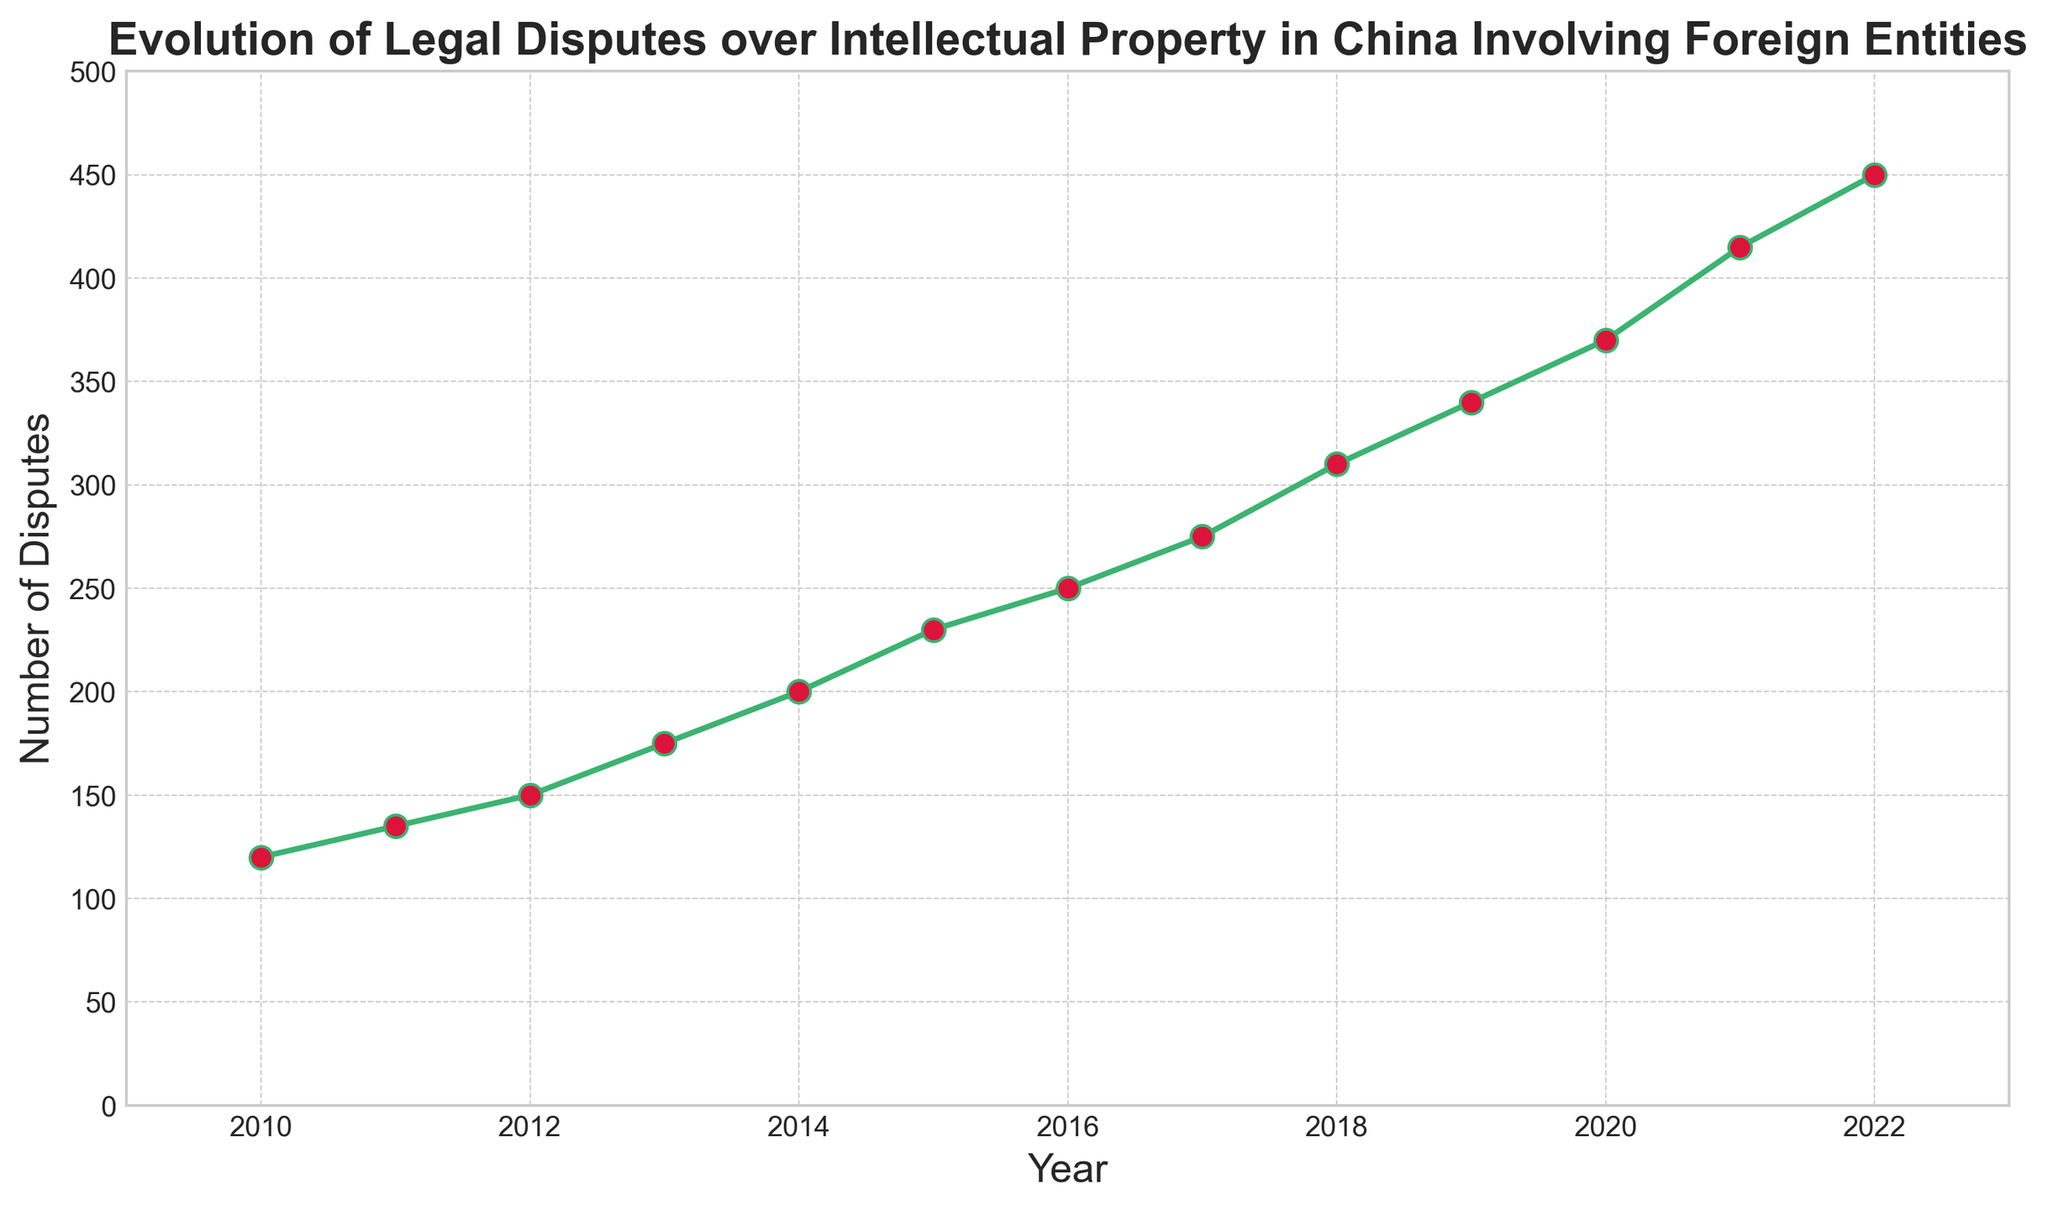What is the trend of the number of legal disputes over intellectual property in China involving foreign entities from 2010 to 2022? The trend shows a steady increase from 120 disputes in 2010 to 450 disputes in 2022. Observing the plot, each subsequent year records a higher number of disputes than the previous year.
Answer: Steady increase What is the total number of legal disputes from 2010 to 2015? Sum the number of disputes from 2010 to 2015: \(120 + 135 + 150 + 175 + 200 + 230 = 1010\).
Answer: 1010 What year had the highest number of legal disputes? The plot shows the highest number of legal disputes in 2022 with 450 disputes.
Answer: 2022 How many more disputes were there in 2022 compared to 2010? Subtract the number of disputes in 2010 from the number in 2022: \(450 - 120 = 330\).
Answer: 330 Which year experienced the largest year-over-year increase in the number of disputes? The plot shows the largest jump between 2020 and 2021, from 370 to 415 disputes. The difference is \(415 - 370 = 45\).
Answer: 2021 What was the average number of legal disputes per year over the given period? Sum the total disputes from 2010 to 2022, which is 3435, and divide by the number of years (13): \(3435 / 13 ≈ 264.23\).
Answer: Approximately 264 How does the number of disputes in 2015 compare to 2018? In 2015, there were 230 disputes, and in 2018, there were 310 disputes. \(310 - 230 = 80\) more disputes in 2018.
Answer: 80 more in 2018 What is the median number of legal disputes per year over this period? For 13 years, the median is the 7th data point when ordered. The number for 2016 (the 7th year) is 250 disputes.
Answer: 250 In which two consecutive years did the number of disputes increase by 25? From 2016 to 2017, the disputes increased from 250 to 275, an increase of \(275 - 250 = 25\).
Answer: 2016 to 2017 What is the difference between the highest and lowest number of disputes recorded in this period? Subtract the lowest number of disputes (120 in 2010) from the highest (450 in 2022): \(450 - 120 = 330\).
Answer: 330 